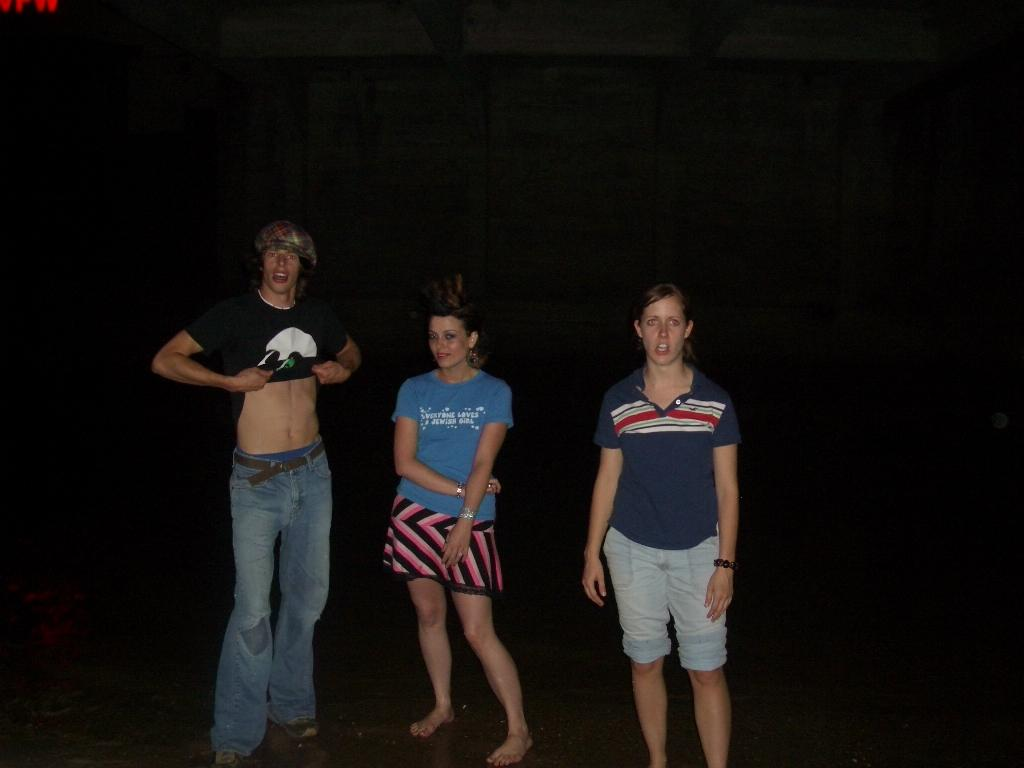<image>
Summarize the visual content of the image. Three people are posing for a photo with the man on the left lifting his shirt. 